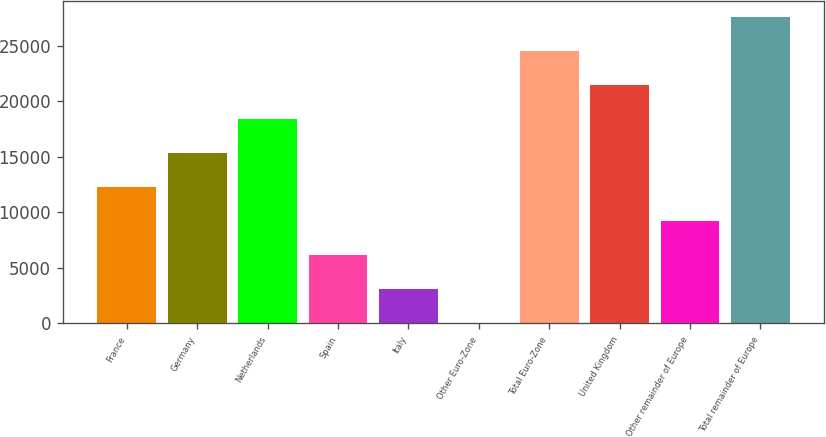<chart> <loc_0><loc_0><loc_500><loc_500><bar_chart><fcel>France<fcel>Germany<fcel>Netherlands<fcel>Spain<fcel>Italy<fcel>Other Euro-Zone<fcel>Total Euro-Zone<fcel>United Kingdom<fcel>Other remainder of Europe<fcel>Total remainder of Europe<nl><fcel>12280.8<fcel>15345.5<fcel>18410.2<fcel>6151.4<fcel>3086.7<fcel>22<fcel>24539.6<fcel>21474.9<fcel>9216.1<fcel>27604.3<nl></chart> 